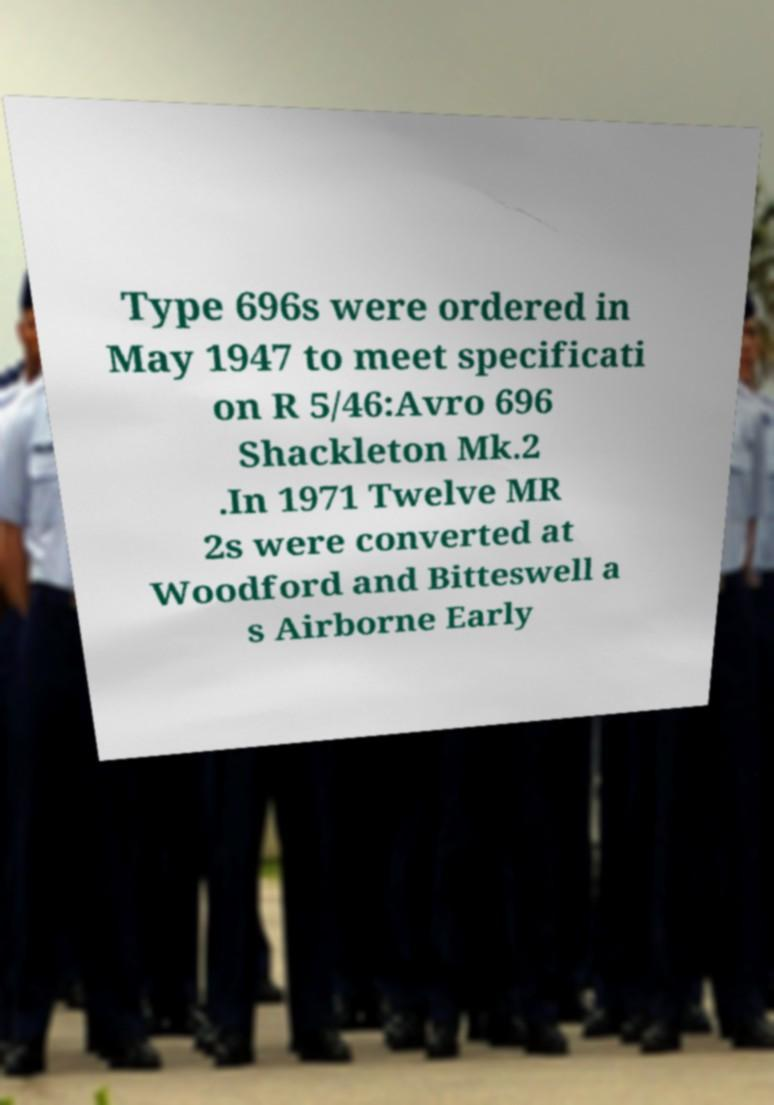For documentation purposes, I need the text within this image transcribed. Could you provide that? Type 696s were ordered in May 1947 to meet specificati on R 5/46:Avro 696 Shackleton Mk.2 .In 1971 Twelve MR 2s were converted at Woodford and Bitteswell a s Airborne Early 